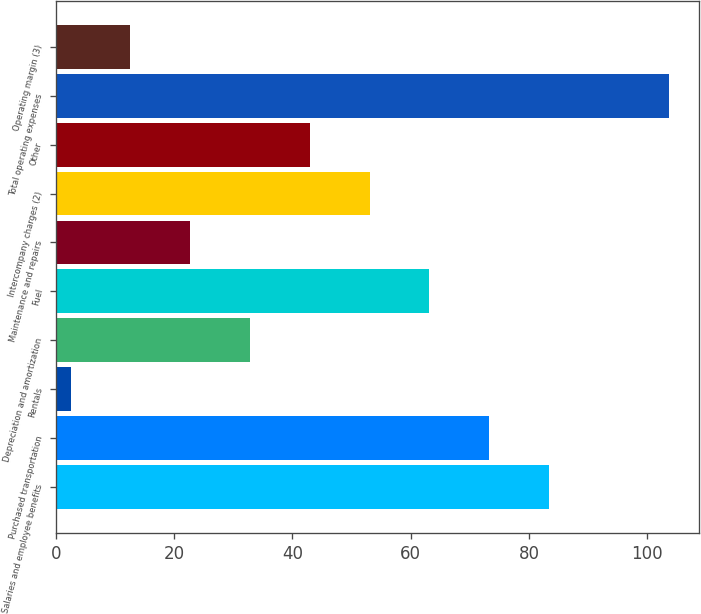Convert chart to OTSL. <chart><loc_0><loc_0><loc_500><loc_500><bar_chart><fcel>Salaries and employee benefits<fcel>Purchased transportation<fcel>Rentals<fcel>Depreciation and amortization<fcel>Fuel<fcel>Maintenance and repairs<fcel>Intercompany charges (2)<fcel>Other<fcel>Total operating expenses<fcel>Operating margin (3)<nl><fcel>83.38<fcel>73.27<fcel>2.5<fcel>32.83<fcel>63.16<fcel>22.72<fcel>53.05<fcel>42.94<fcel>103.6<fcel>12.61<nl></chart> 